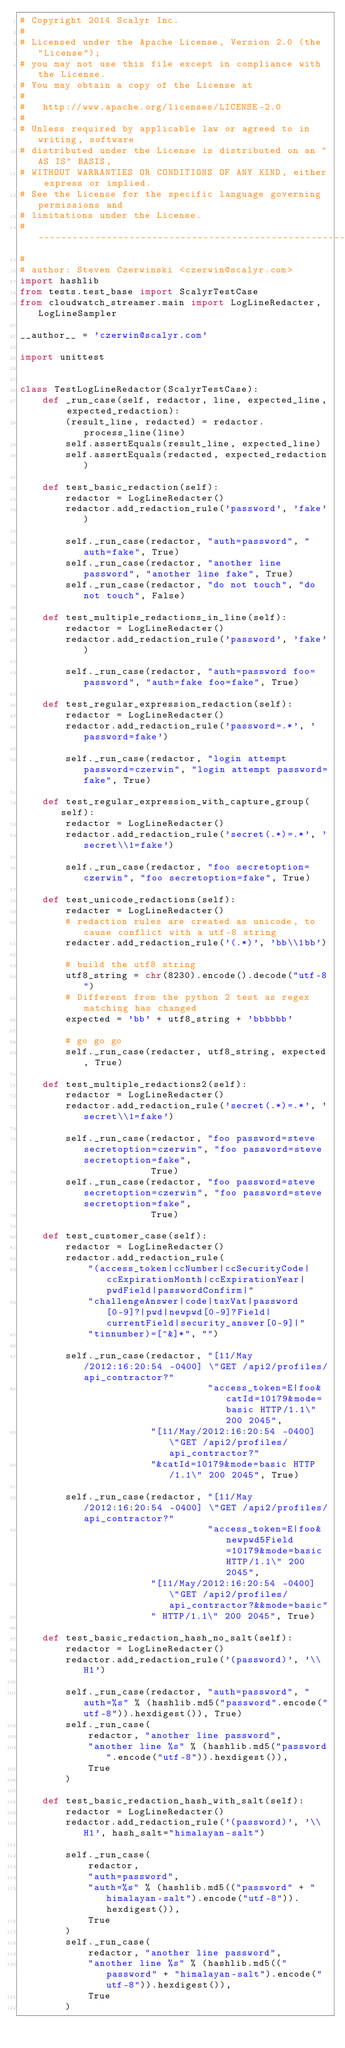Convert code to text. <code><loc_0><loc_0><loc_500><loc_500><_Python_># Copyright 2014 Scalyr Inc.
#
# Licensed under the Apache License, Version 2.0 (the "License");
# you may not use this file except in compliance with the License.
# You may obtain a copy of the License at
#
#   http://www.apache.org/licenses/LICENSE-2.0
#
# Unless required by applicable law or agreed to in writing, software
# distributed under the License is distributed on an "AS IS" BASIS,
# WITHOUT WARRANTIES OR CONDITIONS OF ANY KIND, either express or implied.
# See the License for the specific language governing permissions and
# limitations under the License.
# ------------------------------------------------------------------------
#
# author: Steven Czerwinski <czerwin@scalyr.com>
import hashlib
from tests.test_base import ScalyrTestCase
from cloudwatch_streamer.main import LogLineRedacter, LogLineSampler

__author__ = 'czerwin@scalyr.com'

import unittest


class TestLogLineRedactor(ScalyrTestCase):
    def _run_case(self, redactor, line, expected_line, expected_redaction):
        (result_line, redacted) = redactor.process_line(line)
        self.assertEquals(result_line, expected_line)
        self.assertEquals(redacted, expected_redaction)

    def test_basic_redaction(self):
        redactor = LogLineRedacter()
        redactor.add_redaction_rule('password', 'fake')

        self._run_case(redactor, "auth=password", "auth=fake", True)
        self._run_case(redactor, "another line password", "another line fake", True)
        self._run_case(redactor, "do not touch", "do not touch", False)

    def test_multiple_redactions_in_line(self):
        redactor = LogLineRedacter()
        redactor.add_redaction_rule('password', 'fake')

        self._run_case(redactor, "auth=password foo=password", "auth=fake foo=fake", True)

    def test_regular_expression_redaction(self):
        redactor = LogLineRedacter()
        redactor.add_redaction_rule('password=.*', 'password=fake')

        self._run_case(redactor, "login attempt password=czerwin", "login attempt password=fake", True)

    def test_regular_expression_with_capture_group(self):
        redactor = LogLineRedacter()
        redactor.add_redaction_rule('secret(.*)=.*', 'secret\\1=fake')

        self._run_case(redactor, "foo secretoption=czerwin", "foo secretoption=fake", True)

    def test_unicode_redactions(self):
        redacter = LogLineRedacter()
        # redaction rules are created as unicode, to cause conflict with a utf-8 string
        redacter.add_redaction_rule('(.*)', 'bb\\1bb')

        # build the utf8 string
        utf8_string = chr(8230).encode().decode("utf-8")
        # Different from the python 2 test as regex matching has changed
        expected = 'bb' + utf8_string + 'bbbbbb'

        # go go go
        self._run_case(redacter, utf8_string, expected, True)

    def test_multiple_redactions2(self):
        redactor = LogLineRedacter()
        redactor.add_redaction_rule('secret(.*)=.*', 'secret\\1=fake')

        self._run_case(redactor, "foo password=steve secretoption=czerwin", "foo password=steve secretoption=fake",
                       True)
        self._run_case(redactor, "foo password=steve secretoption=czerwin", "foo password=steve secretoption=fake",
                       True)

    def test_customer_case(self):
        redactor = LogLineRedacter()
        redactor.add_redaction_rule(
            "(access_token|ccNumber|ccSecurityCode|ccExpirationMonth|ccExpirationYear|pwdField|passwordConfirm|"
            "challengeAnswer|code|taxVat|password[0-9]?|pwd|newpwd[0-9]?Field|currentField|security_answer[0-9]|"
            "tinnumber)=[^&]*", "")

        self._run_case(redactor, "[11/May/2012:16:20:54 -0400] \"GET /api2/profiles/api_contractor?"
                                 "access_token=E|foo&catId=10179&mode=basic HTTP/1.1\" 200 2045",
                       "[11/May/2012:16:20:54 -0400] \"GET /api2/profiles/api_contractor?"
                       "&catId=10179&mode=basic HTTP/1.1\" 200 2045", True)

        self._run_case(redactor, "[11/May/2012:16:20:54 -0400] \"GET /api2/profiles/api_contractor?"
                                 "access_token=E|foo&newpwd5Field=10179&mode=basic HTTP/1.1\" 200 2045",
                       "[11/May/2012:16:20:54 -0400] \"GET /api2/profiles/api_contractor?&&mode=basic"
                       " HTTP/1.1\" 200 2045", True)

    def test_basic_redaction_hash_no_salt(self):
        redactor = LogLineRedacter()
        redactor.add_redaction_rule('(password)', '\\H1')

        self._run_case(redactor, "auth=password", "auth=%s" % (hashlib.md5("password".encode("utf-8")).hexdigest()), True)
        self._run_case(
            redactor, "another line password",
            "another line %s" % (hashlib.md5("password".encode("utf-8")).hexdigest()),
            True
        )

    def test_basic_redaction_hash_with_salt(self):
        redactor = LogLineRedacter()
        redactor.add_redaction_rule('(password)', '\\H1', hash_salt="himalayan-salt")

        self._run_case(
            redactor,
            "auth=password",
            "auth=%s" % (hashlib.md5(("password" + "himalayan-salt").encode("utf-8")).hexdigest()),
            True
        )
        self._run_case(
            redactor, "another line password",
            "another line %s" % (hashlib.md5(("password" + "himalayan-salt").encode("utf-8")).hexdigest()),
            True
        )
</code> 